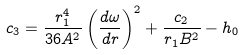Convert formula to latex. <formula><loc_0><loc_0><loc_500><loc_500>c _ { 3 } = \frac { r _ { 1 } ^ { 4 } } { 3 6 A ^ { 2 } } \left ( \frac { d \omega } { d r } \right ) ^ { 2 } + \frac { c _ { 2 } } { r _ { 1 } B ^ { 2 } } - h _ { 0 }</formula> 